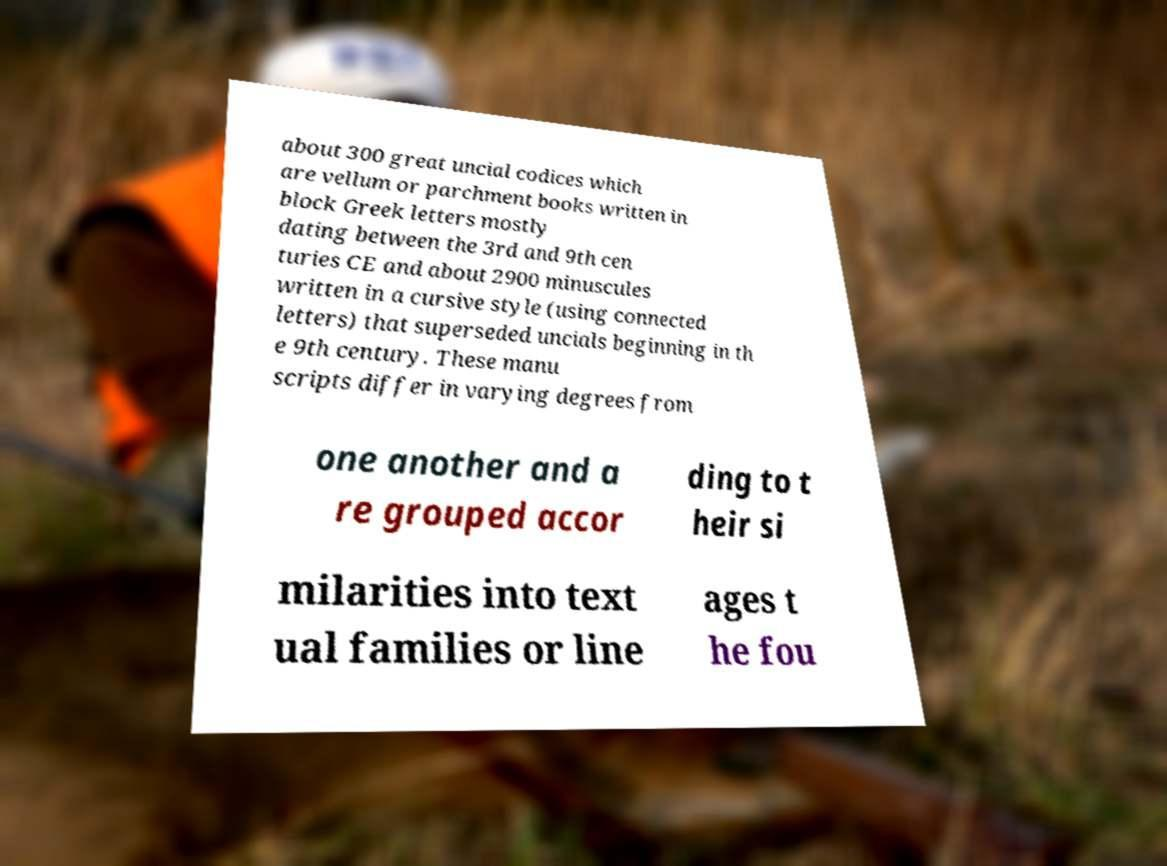For documentation purposes, I need the text within this image transcribed. Could you provide that? about 300 great uncial codices which are vellum or parchment books written in block Greek letters mostly dating between the 3rd and 9th cen turies CE and about 2900 minuscules written in a cursive style (using connected letters) that superseded uncials beginning in th e 9th century. These manu scripts differ in varying degrees from one another and a re grouped accor ding to t heir si milarities into text ual families or line ages t he fou 